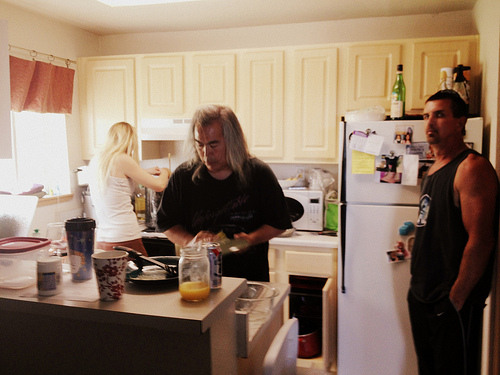<image>
Is there a microwave on the fridge? No. The microwave is not positioned on the fridge. They may be near each other, but the microwave is not supported by or resting on top of the fridge. 